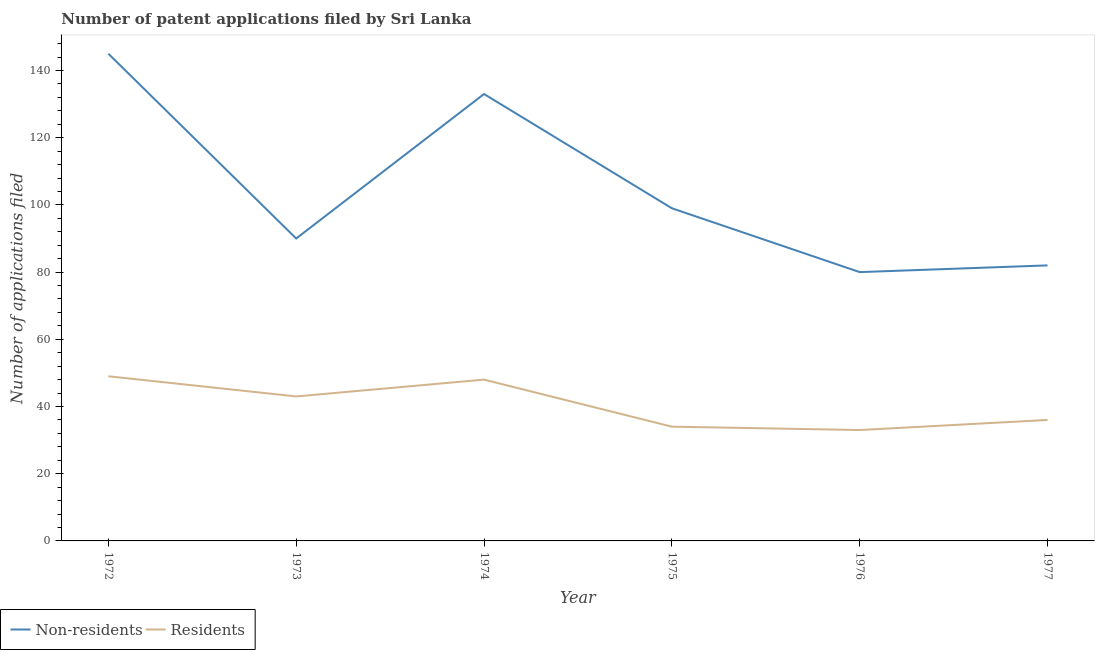What is the number of patent applications by residents in 1977?
Provide a short and direct response. 36. Across all years, what is the maximum number of patent applications by residents?
Provide a succinct answer. 49. Across all years, what is the minimum number of patent applications by non residents?
Offer a very short reply. 80. In which year was the number of patent applications by residents maximum?
Give a very brief answer. 1972. In which year was the number of patent applications by non residents minimum?
Ensure brevity in your answer.  1976. What is the total number of patent applications by non residents in the graph?
Offer a very short reply. 629. What is the difference between the number of patent applications by residents in 1976 and that in 1977?
Your answer should be very brief. -3. What is the difference between the number of patent applications by residents in 1972 and the number of patent applications by non residents in 1975?
Give a very brief answer. -50. What is the average number of patent applications by non residents per year?
Give a very brief answer. 104.83. In the year 1976, what is the difference between the number of patent applications by non residents and number of patent applications by residents?
Your answer should be very brief. 47. In how many years, is the number of patent applications by residents greater than 132?
Your response must be concise. 0. What is the ratio of the number of patent applications by residents in 1976 to that in 1977?
Offer a terse response. 0.92. Is the difference between the number of patent applications by non residents in 1973 and 1975 greater than the difference between the number of patent applications by residents in 1973 and 1975?
Give a very brief answer. No. What is the difference between the highest and the lowest number of patent applications by non residents?
Offer a very short reply. 65. Is the number of patent applications by non residents strictly greater than the number of patent applications by residents over the years?
Your answer should be compact. Yes. What is the difference between two consecutive major ticks on the Y-axis?
Provide a short and direct response. 20. Does the graph contain any zero values?
Your answer should be very brief. No. Does the graph contain grids?
Provide a short and direct response. No. How many legend labels are there?
Ensure brevity in your answer.  2. What is the title of the graph?
Offer a terse response. Number of patent applications filed by Sri Lanka. Does "Nonresident" appear as one of the legend labels in the graph?
Keep it short and to the point. No. What is the label or title of the Y-axis?
Your answer should be compact. Number of applications filed. What is the Number of applications filed of Non-residents in 1972?
Provide a succinct answer. 145. What is the Number of applications filed in Non-residents in 1973?
Give a very brief answer. 90. What is the Number of applications filed of Non-residents in 1974?
Offer a terse response. 133. What is the Number of applications filed of Non-residents in 1975?
Give a very brief answer. 99. What is the Number of applications filed of Non-residents in 1976?
Ensure brevity in your answer.  80. Across all years, what is the maximum Number of applications filed of Non-residents?
Give a very brief answer. 145. Across all years, what is the minimum Number of applications filed in Residents?
Provide a short and direct response. 33. What is the total Number of applications filed in Non-residents in the graph?
Offer a terse response. 629. What is the total Number of applications filed in Residents in the graph?
Offer a terse response. 243. What is the difference between the Number of applications filed of Non-residents in 1972 and that in 1973?
Keep it short and to the point. 55. What is the difference between the Number of applications filed of Residents in 1972 and that in 1973?
Your answer should be compact. 6. What is the difference between the Number of applications filed in Residents in 1972 and that in 1974?
Your response must be concise. 1. What is the difference between the Number of applications filed of Residents in 1972 and that in 1975?
Make the answer very short. 15. What is the difference between the Number of applications filed in Non-residents in 1972 and that in 1977?
Offer a terse response. 63. What is the difference between the Number of applications filed in Residents in 1972 and that in 1977?
Your answer should be compact. 13. What is the difference between the Number of applications filed in Non-residents in 1973 and that in 1974?
Ensure brevity in your answer.  -43. What is the difference between the Number of applications filed in Non-residents in 1973 and that in 1975?
Provide a succinct answer. -9. What is the difference between the Number of applications filed of Non-residents in 1973 and that in 1976?
Provide a short and direct response. 10. What is the difference between the Number of applications filed of Residents in 1973 and that in 1976?
Your answer should be very brief. 10. What is the difference between the Number of applications filed in Residents in 1973 and that in 1977?
Make the answer very short. 7. What is the difference between the Number of applications filed in Non-residents in 1974 and that in 1975?
Your response must be concise. 34. What is the difference between the Number of applications filed of Residents in 1974 and that in 1976?
Give a very brief answer. 15. What is the difference between the Number of applications filed of Non-residents in 1975 and that in 1976?
Give a very brief answer. 19. What is the difference between the Number of applications filed in Non-residents in 1975 and that in 1977?
Ensure brevity in your answer.  17. What is the difference between the Number of applications filed of Residents in 1976 and that in 1977?
Ensure brevity in your answer.  -3. What is the difference between the Number of applications filed in Non-residents in 1972 and the Number of applications filed in Residents in 1973?
Your response must be concise. 102. What is the difference between the Number of applications filed in Non-residents in 1972 and the Number of applications filed in Residents in 1974?
Give a very brief answer. 97. What is the difference between the Number of applications filed of Non-residents in 1972 and the Number of applications filed of Residents in 1975?
Offer a very short reply. 111. What is the difference between the Number of applications filed in Non-residents in 1972 and the Number of applications filed in Residents in 1976?
Ensure brevity in your answer.  112. What is the difference between the Number of applications filed in Non-residents in 1972 and the Number of applications filed in Residents in 1977?
Your response must be concise. 109. What is the difference between the Number of applications filed in Non-residents in 1973 and the Number of applications filed in Residents in 1975?
Your answer should be compact. 56. What is the difference between the Number of applications filed of Non-residents in 1973 and the Number of applications filed of Residents in 1977?
Provide a short and direct response. 54. What is the difference between the Number of applications filed of Non-residents in 1974 and the Number of applications filed of Residents in 1976?
Give a very brief answer. 100. What is the difference between the Number of applications filed in Non-residents in 1974 and the Number of applications filed in Residents in 1977?
Your answer should be very brief. 97. What is the difference between the Number of applications filed in Non-residents in 1975 and the Number of applications filed in Residents in 1976?
Provide a short and direct response. 66. What is the difference between the Number of applications filed of Non-residents in 1976 and the Number of applications filed of Residents in 1977?
Keep it short and to the point. 44. What is the average Number of applications filed of Non-residents per year?
Provide a succinct answer. 104.83. What is the average Number of applications filed of Residents per year?
Your response must be concise. 40.5. In the year 1972, what is the difference between the Number of applications filed in Non-residents and Number of applications filed in Residents?
Your response must be concise. 96. In the year 1973, what is the difference between the Number of applications filed in Non-residents and Number of applications filed in Residents?
Offer a very short reply. 47. In the year 1974, what is the difference between the Number of applications filed in Non-residents and Number of applications filed in Residents?
Ensure brevity in your answer.  85. In the year 1975, what is the difference between the Number of applications filed in Non-residents and Number of applications filed in Residents?
Ensure brevity in your answer.  65. What is the ratio of the Number of applications filed of Non-residents in 1972 to that in 1973?
Your answer should be very brief. 1.61. What is the ratio of the Number of applications filed in Residents in 1972 to that in 1973?
Offer a very short reply. 1.14. What is the ratio of the Number of applications filed in Non-residents in 1972 to that in 1974?
Your response must be concise. 1.09. What is the ratio of the Number of applications filed of Residents in 1972 to that in 1974?
Keep it short and to the point. 1.02. What is the ratio of the Number of applications filed in Non-residents in 1972 to that in 1975?
Keep it short and to the point. 1.46. What is the ratio of the Number of applications filed in Residents in 1972 to that in 1975?
Offer a terse response. 1.44. What is the ratio of the Number of applications filed in Non-residents in 1972 to that in 1976?
Give a very brief answer. 1.81. What is the ratio of the Number of applications filed in Residents in 1972 to that in 1976?
Your answer should be very brief. 1.48. What is the ratio of the Number of applications filed in Non-residents in 1972 to that in 1977?
Offer a very short reply. 1.77. What is the ratio of the Number of applications filed in Residents in 1972 to that in 1977?
Keep it short and to the point. 1.36. What is the ratio of the Number of applications filed of Non-residents in 1973 to that in 1974?
Make the answer very short. 0.68. What is the ratio of the Number of applications filed in Residents in 1973 to that in 1974?
Your answer should be compact. 0.9. What is the ratio of the Number of applications filed of Residents in 1973 to that in 1975?
Offer a very short reply. 1.26. What is the ratio of the Number of applications filed of Non-residents in 1973 to that in 1976?
Offer a terse response. 1.12. What is the ratio of the Number of applications filed in Residents in 1973 to that in 1976?
Provide a short and direct response. 1.3. What is the ratio of the Number of applications filed of Non-residents in 1973 to that in 1977?
Make the answer very short. 1.1. What is the ratio of the Number of applications filed in Residents in 1973 to that in 1977?
Offer a very short reply. 1.19. What is the ratio of the Number of applications filed of Non-residents in 1974 to that in 1975?
Offer a terse response. 1.34. What is the ratio of the Number of applications filed of Residents in 1974 to that in 1975?
Provide a short and direct response. 1.41. What is the ratio of the Number of applications filed of Non-residents in 1974 to that in 1976?
Ensure brevity in your answer.  1.66. What is the ratio of the Number of applications filed in Residents in 1974 to that in 1976?
Your response must be concise. 1.45. What is the ratio of the Number of applications filed in Non-residents in 1974 to that in 1977?
Offer a terse response. 1.62. What is the ratio of the Number of applications filed in Non-residents in 1975 to that in 1976?
Your response must be concise. 1.24. What is the ratio of the Number of applications filed of Residents in 1975 to that in 1976?
Ensure brevity in your answer.  1.03. What is the ratio of the Number of applications filed in Non-residents in 1975 to that in 1977?
Give a very brief answer. 1.21. What is the ratio of the Number of applications filed of Residents in 1975 to that in 1977?
Provide a succinct answer. 0.94. What is the ratio of the Number of applications filed of Non-residents in 1976 to that in 1977?
Provide a succinct answer. 0.98. What is the ratio of the Number of applications filed of Residents in 1976 to that in 1977?
Offer a terse response. 0.92. What is the difference between the highest and the second highest Number of applications filed of Non-residents?
Your response must be concise. 12. What is the difference between the highest and the second highest Number of applications filed of Residents?
Your answer should be very brief. 1. What is the difference between the highest and the lowest Number of applications filed of Non-residents?
Offer a very short reply. 65. What is the difference between the highest and the lowest Number of applications filed of Residents?
Your answer should be compact. 16. 